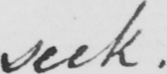Please transcribe the handwritten text in this image. seek 